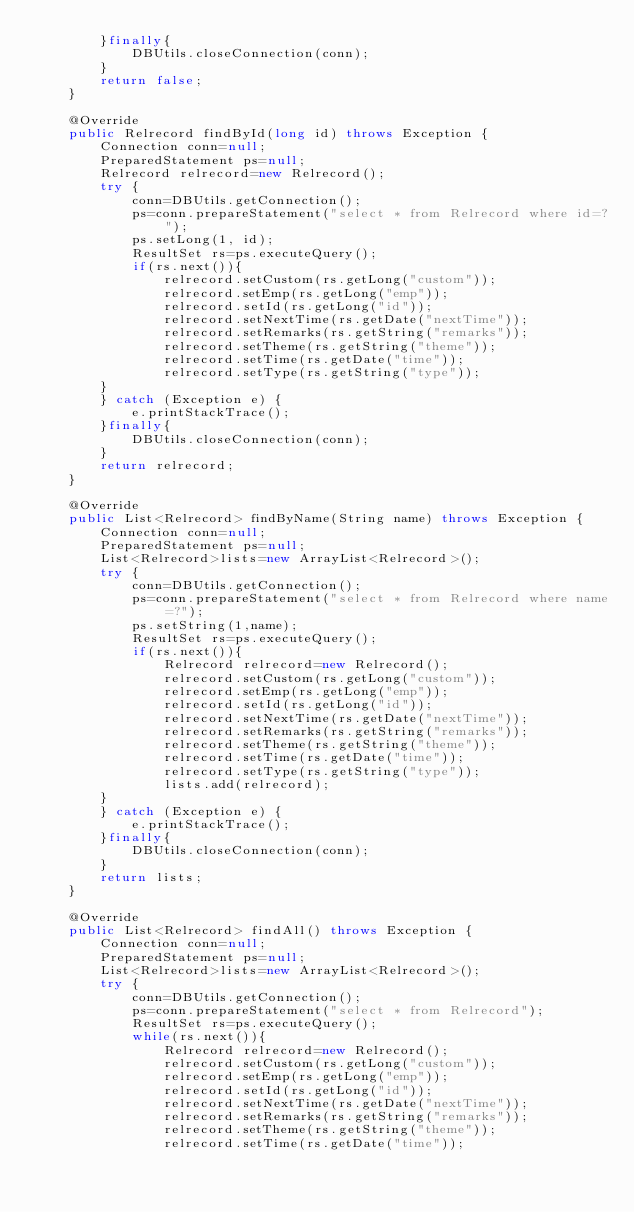Convert code to text. <code><loc_0><loc_0><loc_500><loc_500><_Java_>		}finally{
			DBUtils.closeConnection(conn);
		}
		return false;
	}

	@Override
	public Relrecord findById(long id) throws Exception {
		Connection conn=null;
		PreparedStatement ps=null;
		Relrecord relrecord=new Relrecord();
		try {
			conn=DBUtils.getConnection();
			ps=conn.prepareStatement("select * from Relrecord where id=?");
			ps.setLong(1, id);
			ResultSet rs=ps.executeQuery();
			if(rs.next()){
				relrecord.setCustom(rs.getLong("custom"));
				relrecord.setEmp(rs.getLong("emp"));
				relrecord.setId(rs.getLong("id"));
				relrecord.setNextTime(rs.getDate("nextTime"));
				relrecord.setRemarks(rs.getString("remarks"));
				relrecord.setTheme(rs.getString("theme"));
				relrecord.setTime(rs.getDate("time"));
				relrecord.setType(rs.getString("type"));
		}
		} catch (Exception e) {
			e.printStackTrace();
		}finally{
			DBUtils.closeConnection(conn);
		}
		return relrecord;
	}

	@Override
	public List<Relrecord> findByName(String name) throws Exception {
		Connection conn=null;
		PreparedStatement ps=null;
		List<Relrecord>lists=new ArrayList<Relrecord>();
		try {
			conn=DBUtils.getConnection();
			ps=conn.prepareStatement("select * from Relrecord where name=?");
			ps.setString(1,name);
			ResultSet rs=ps.executeQuery();
			if(rs.next()){
				Relrecord relrecord=new Relrecord();
				relrecord.setCustom(rs.getLong("custom"));
				relrecord.setEmp(rs.getLong("emp"));
				relrecord.setId(rs.getLong("id"));
				relrecord.setNextTime(rs.getDate("nextTime"));
				relrecord.setRemarks(rs.getString("remarks"));
				relrecord.setTheme(rs.getString("theme"));
				relrecord.setTime(rs.getDate("time"));
				relrecord.setType(rs.getString("type"));
				lists.add(relrecord);
		}
		} catch (Exception e) {
			e.printStackTrace();
		}finally{
			DBUtils.closeConnection(conn);
		}
		return lists;
	}

	@Override
	public List<Relrecord> findAll() throws Exception {
		Connection conn=null;
		PreparedStatement ps=null;
		List<Relrecord>lists=new ArrayList<Relrecord>();
		try {
			conn=DBUtils.getConnection();
			ps=conn.prepareStatement("select * from Relrecord");
			ResultSet rs=ps.executeQuery();
			while(rs.next()){
				Relrecord relrecord=new Relrecord();
				relrecord.setCustom(rs.getLong("custom"));
				relrecord.setEmp(rs.getLong("emp"));
				relrecord.setId(rs.getLong("id"));
				relrecord.setNextTime(rs.getDate("nextTime"));
				relrecord.setRemarks(rs.getString("remarks"));
				relrecord.setTheme(rs.getString("theme"));
				relrecord.setTime(rs.getDate("time"));</code> 